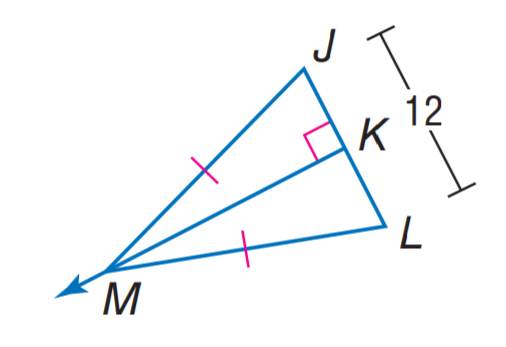Answer the mathemtical geometry problem and directly provide the correct option letter.
Question: Find K L.
Choices: A: 3 B: 6 C: 12 D: 18 B 